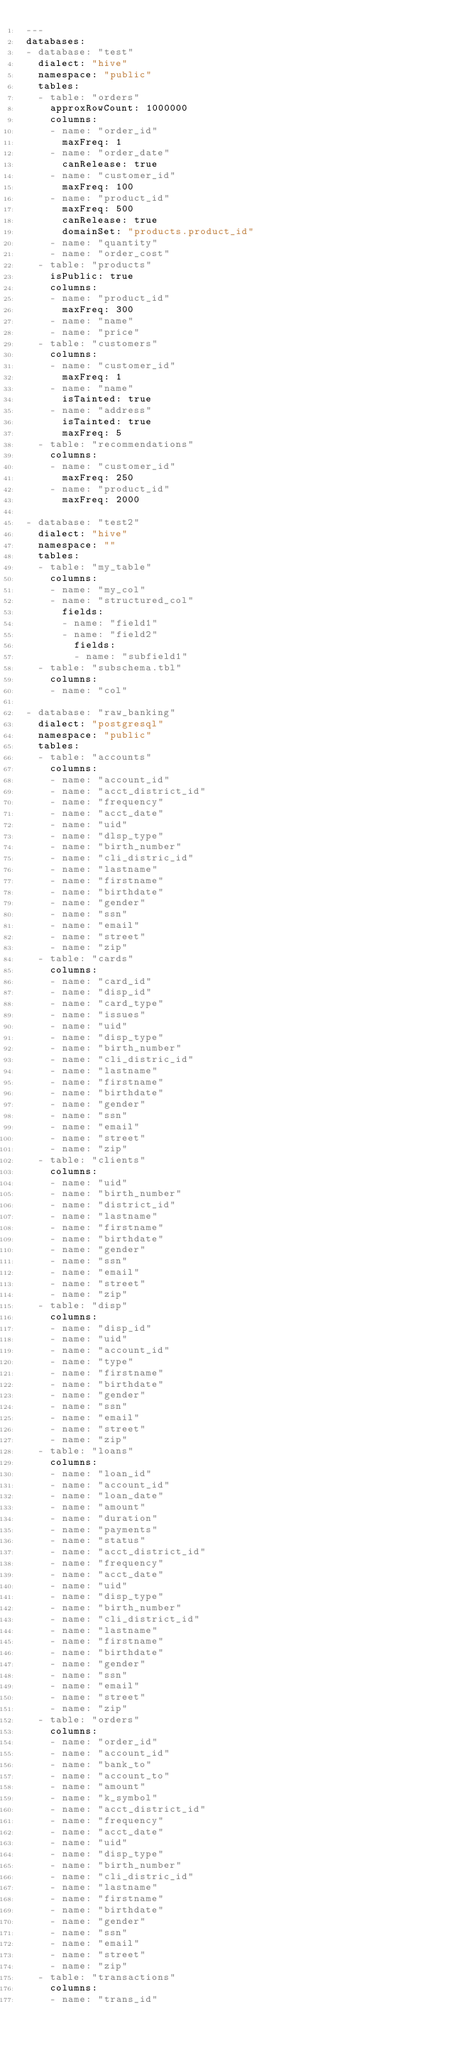Convert code to text. <code><loc_0><loc_0><loc_500><loc_500><_YAML_>---
databases:
- database: "test"
  dialect: "hive"
  namespace: "public"
  tables:
  - table: "orders"
    approxRowCount: 1000000
    columns:
    - name: "order_id"
      maxFreq: 1
    - name: "order_date"
      canRelease: true
    - name: "customer_id"
      maxFreq: 100
    - name: "product_id"
      maxFreq: 500
      canRelease: true
      domainSet: "products.product_id"
    - name: "quantity"
    - name: "order_cost"
  - table: "products"
    isPublic: true
    columns:
    - name: "product_id"
      maxFreq: 300
    - name: "name"
    - name: "price"
  - table: "customers"
    columns:
    - name: "customer_id"
      maxFreq: 1
    - name: "name"
      isTainted: true
    - name: "address"
      isTainted: true
      maxFreq: 5
  - table: "recommendations"
    columns:
    - name: "customer_id"
      maxFreq: 250
    - name: "product_id"
      maxFreq: 2000

- database: "test2"
  dialect: "hive"
  namespace: ""
  tables:
  - table: "my_table"
    columns:
    - name: "my_col"
    - name: "structured_col"
      fields:
      - name: "field1"
      - name: "field2"
        fields:
        - name: "subfield1"
  - table: "subschema.tbl"
    columns:
    - name: "col"

- database: "raw_banking"
  dialect: "postgresql"
  namespace: "public"
  tables:
  - table: "accounts"
    columns:
    - name: "account_id"
    - name: "acct_district_id"
    - name: "frequency"
    - name: "acct_date"
    - name: "uid"
    - name: "dlsp_type"
    - name: "birth_number"
    - name: "cli_distric_id"
    - name: "lastname"
    - name: "firstname"
    - name: "birthdate"
    - name: "gender"
    - name: "ssn"
    - name: "email"
    - name: "street"
    - name: "zip"
  - table: "cards"
    columns:
    - name: "card_id"
    - name: "disp_id"
    - name: "card_type"
    - name: "issues"
    - name: "uid"
    - name: "disp_type"
    - name: "birth_number"
    - name: "cli_distric_id"
    - name: "lastname"
    - name: "firstname"
    - name: "birthdate"
    - name: "gender"
    - name: "ssn"
    - name: "email"
    - name: "street"
    - name: "zip"
  - table: "clients"
    columns:
    - name: "uid"
    - name: "birth_number"
    - name: "district_id"
    - name: "lastname"
    - name: "firstname"
    - name: "birthdate"
    - name: "gender"
    - name: "ssn"
    - name: "email"
    - name: "street"
    - name: "zip"
  - table: "disp"
    columns:
    - name: "disp_id"
    - name: "uid"
    - name: "account_id"
    - name: "type"
    - name: "firstname"
    - name: "birthdate"
    - name: "gender"
    - name: "ssn"
    - name: "email"
    - name: "street"
    - name: "zip"
  - table: "loans"
    columns:
    - name: "loan_id"
    - name: "account_id"
    - name: "loan_date"
    - name: "amount"
    - name: "duration"
    - name: "payments"
    - name: "status"
    - name: "acct_district_id"
    - name: "frequency"
    - name: "acct_date"
    - name: "uid"
    - name: "disp_type"
    - name: "birth_number"
    - name: "cli_district_id"
    - name: "lastname"
    - name: "firstname"
    - name: "birthdate"
    - name: "gender"
    - name: "ssn"
    - name: "email"
    - name: "street"
    - name: "zip"
  - table: "orders"
    columns:
    - name: "order_id"
    - name: "account_id"
    - name: "bank_to"
    - name: "account_to"
    - name: "amount"
    - name: "k_symbol"
    - name: "acct_district_id"
    - name: "frequency"
    - name: "acct_date"
    - name: "uid"
    - name: "disp_type"
    - name: "birth_number"
    - name: "cli_distric_id"
    - name: "lastname"
    - name: "firstname"
    - name: "birthdate"
    - name: "gender"
    - name: "ssn"
    - name: "email"
    - name: "street"
    - name: "zip"
  - table: "transactions"
    columns:
    - name: "trans_id"</code> 